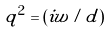Convert formula to latex. <formula><loc_0><loc_0><loc_500><loc_500>q ^ { 2 } = ( i w / d )</formula> 